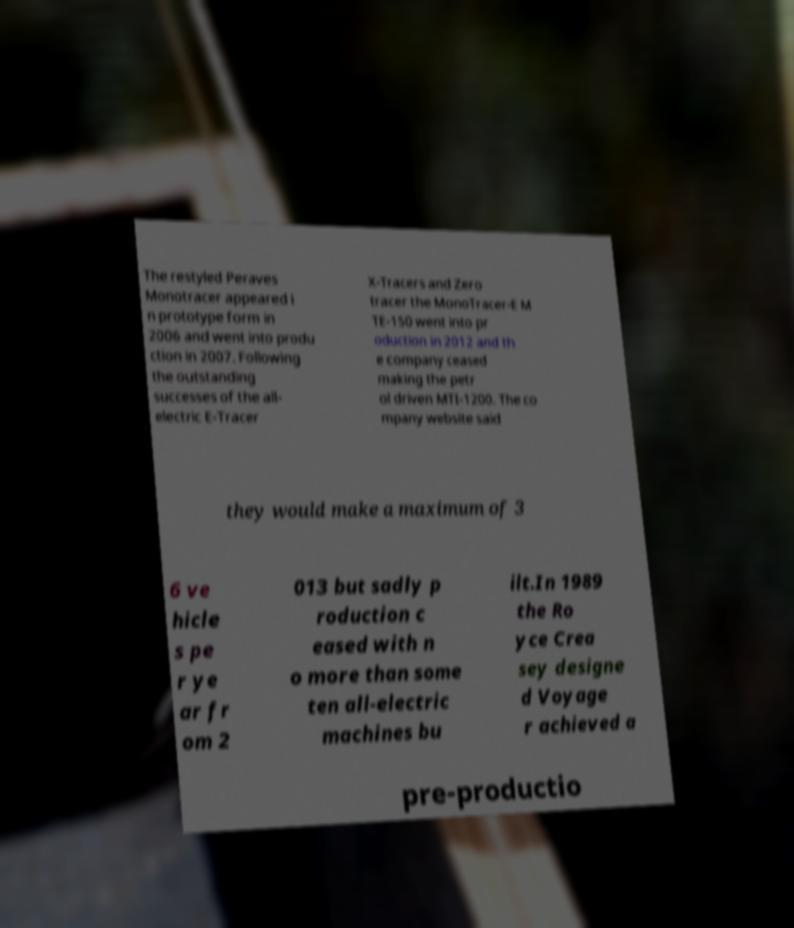Please identify and transcribe the text found in this image. The restyled Peraves Monotracer appeared i n prototype form in 2006 and went into produ ction in 2007. Following the outstanding successes of the all- electric E-Tracer X-Tracers and Zero tracer the MonoTracer-E M TE-150 went into pr oduction in 2012 and th e company ceased making the petr ol driven MTI-1200. The co mpany website said they would make a maximum of 3 6 ve hicle s pe r ye ar fr om 2 013 but sadly p roduction c eased with n o more than some ten all-electric machines bu ilt.In 1989 the Ro yce Crea sey designe d Voyage r achieved a pre-productio 